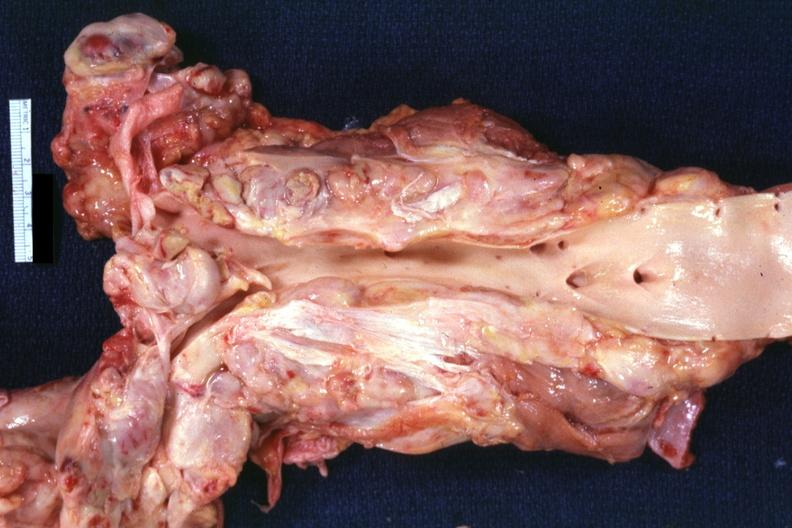s lymph node present?
Answer the question using a single word or phrase. Yes 